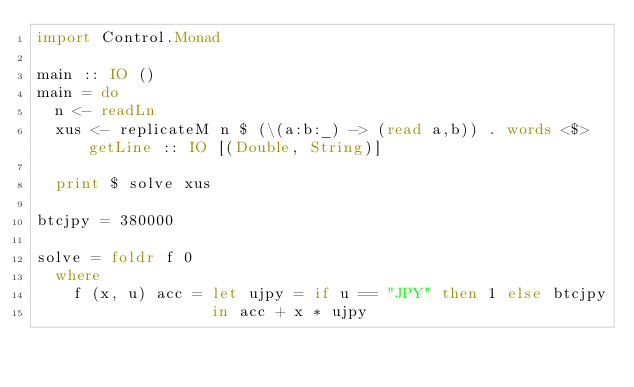<code> <loc_0><loc_0><loc_500><loc_500><_Haskell_>import Control.Monad

main :: IO ()
main = do
  n <- readLn
  xus <- replicateM n $ (\(a:b:_) -> (read a,b)) . words <$> getLine :: IO [(Double, String)]

  print $ solve xus

btcjpy = 380000

solve = foldr f 0 
  where
    f (x, u) acc = let ujpy = if u == "JPY" then 1 else btcjpy
                   in acc + x * ujpy</code> 